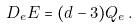<formula> <loc_0><loc_0><loc_500><loc_500>D _ { e } E = ( d - 3 ) Q _ { e } \, .</formula> 